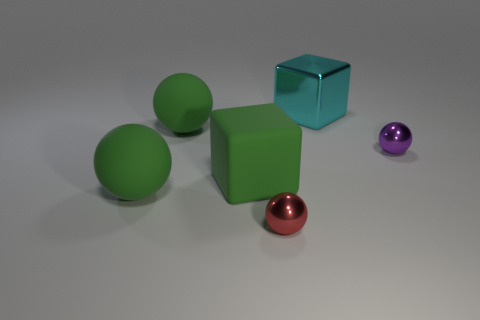There is a ball that is to the right of the small red sphere; is its size the same as the green matte ball behind the purple metallic sphere?
Ensure brevity in your answer.  No. There is a cyan metal thing that is behind the red thing; what shape is it?
Provide a succinct answer. Cube. There is another tiny object that is the same shape as the purple shiny thing; what material is it?
Ensure brevity in your answer.  Metal. There is a metallic thing that is in front of the rubber cube; is its size the same as the matte cube?
Give a very brief answer. No. How many rubber objects are on the right side of the small red thing?
Make the answer very short. 0. Are there fewer large rubber spheres in front of the large metal cube than cyan objects that are to the left of the matte cube?
Provide a succinct answer. No. What number of cyan matte cylinders are there?
Provide a succinct answer. 0. The block in front of the big cyan metal cube is what color?
Make the answer very short. Green. How big is the purple metal object?
Offer a very short reply. Small. Is the color of the large shiny object the same as the matte sphere behind the green block?
Ensure brevity in your answer.  No. 